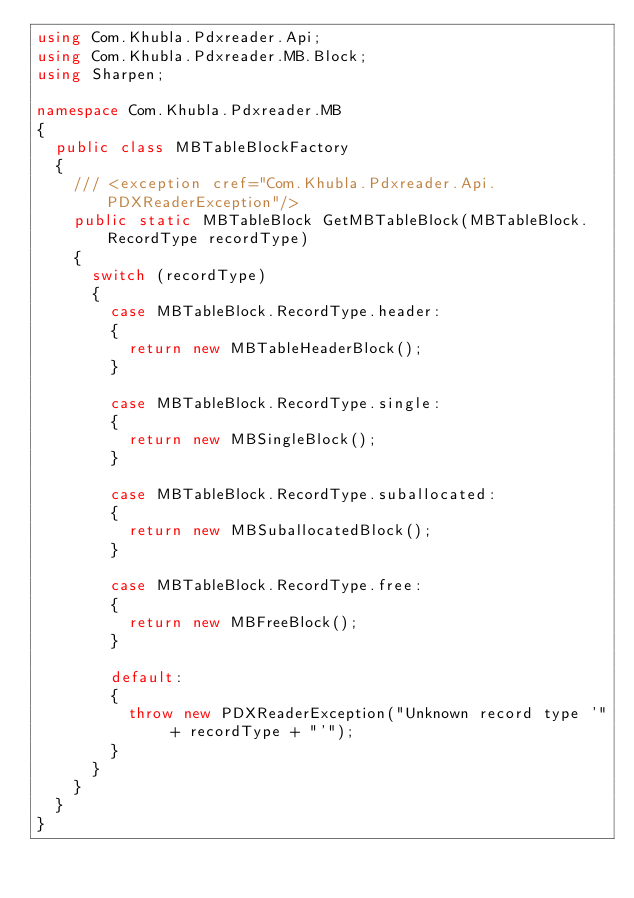<code> <loc_0><loc_0><loc_500><loc_500><_C#_>using Com.Khubla.Pdxreader.Api;
using Com.Khubla.Pdxreader.MB.Block;
using Sharpen;

namespace Com.Khubla.Pdxreader.MB
{
	public class MBTableBlockFactory
	{
		/// <exception cref="Com.Khubla.Pdxreader.Api.PDXReaderException"/>
		public static MBTableBlock GetMBTableBlock(MBTableBlock.RecordType recordType)
		{
			switch (recordType)
			{
				case MBTableBlock.RecordType.header:
				{
					return new MBTableHeaderBlock();
				}

				case MBTableBlock.RecordType.single:
				{
					return new MBSingleBlock();
				}

				case MBTableBlock.RecordType.suballocated:
				{
					return new MBSuballocatedBlock();
				}

				case MBTableBlock.RecordType.free:
				{
					return new MBFreeBlock();
				}

				default:
				{
					throw new PDXReaderException("Unknown record type '" + recordType + "'");
				}
			}
		}
	}
}
</code> 